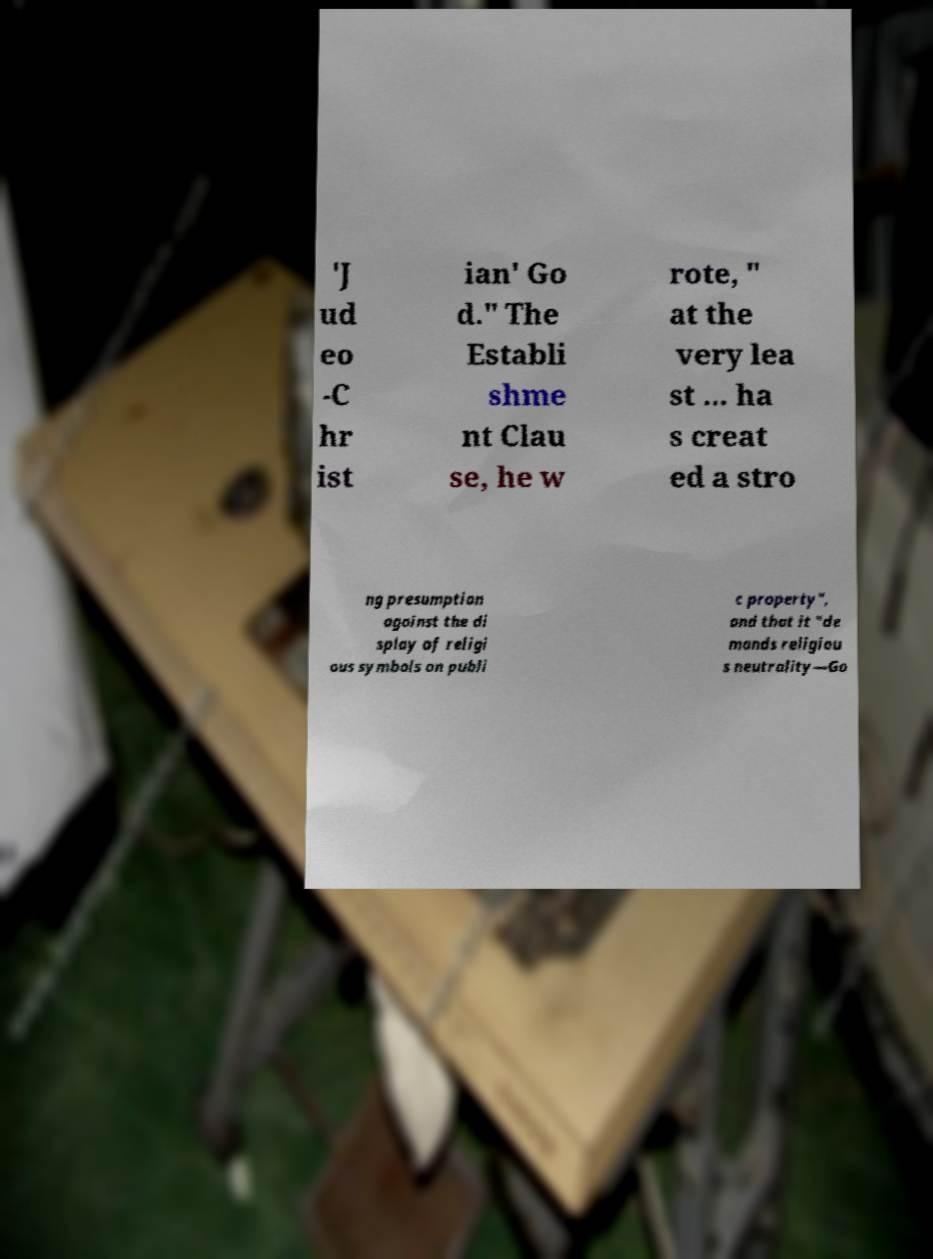Could you assist in decoding the text presented in this image and type it out clearly? 'J ud eo -C hr ist ian' Go d." The Establi shme nt Clau se, he w rote, " at the very lea st ... ha s creat ed a stro ng presumption against the di splay of religi ous symbols on publi c property", and that it "de mands religiou s neutrality—Go 